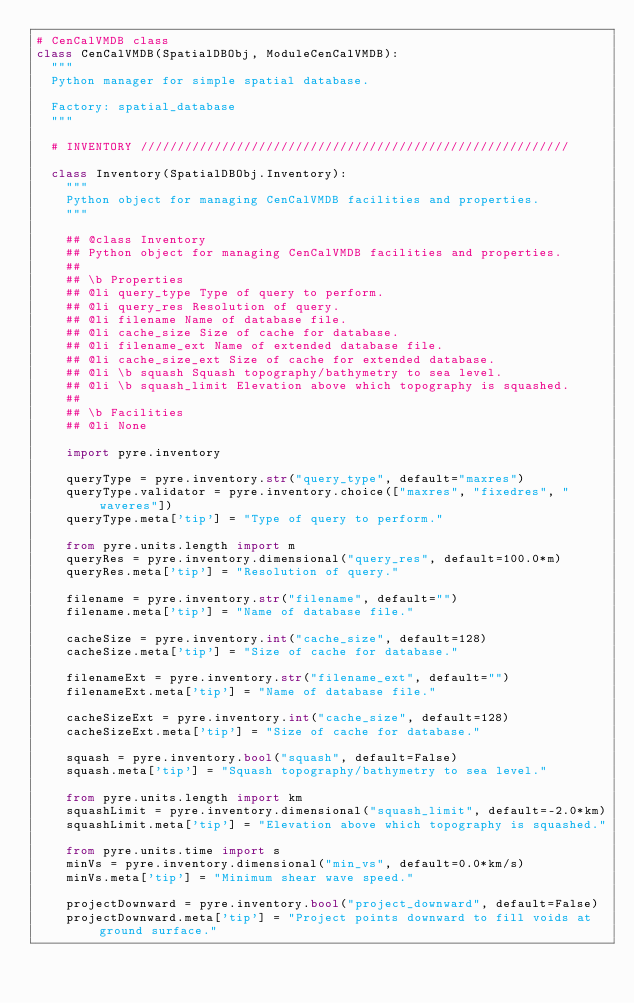<code> <loc_0><loc_0><loc_500><loc_500><_Python_># CenCalVMDB class
class CenCalVMDB(SpatialDBObj, ModuleCenCalVMDB):
  """
  Python manager for simple spatial database.

  Factory: spatial_database
  """

  # INVENTORY //////////////////////////////////////////////////////////

  class Inventory(SpatialDBObj.Inventory):
    """
    Python object for managing CenCalVMDB facilities and properties.
    """

    ## @class Inventory
    ## Python object for managing CenCalVMDB facilities and properties.
    ##
    ## \b Properties
    ## @li query_type Type of query to perform.
    ## @li query_res Resolution of query.
    ## @li filename Name of database file.
    ## @li cache_size Size of cache for database.
    ## @li filename_ext Name of extended database file.
    ## @li cache_size_ext Size of cache for extended database.
    ## @li \b squash Squash topography/bathymetry to sea level.
    ## @li \b squash_limit Elevation above which topography is squashed.
    ##
    ## \b Facilities
    ## @li None

    import pyre.inventory

    queryType = pyre.inventory.str("query_type", default="maxres")
    queryType.validator = pyre.inventory.choice(["maxres", "fixedres", "waveres"])
    queryType.meta['tip'] = "Type of query to perform."

    from pyre.units.length import m
    queryRes = pyre.inventory.dimensional("query_res", default=100.0*m)
    queryRes.meta['tip'] = "Resolution of query."

    filename = pyre.inventory.str("filename", default="")
    filename.meta['tip'] = "Name of database file."

    cacheSize = pyre.inventory.int("cache_size", default=128)
    cacheSize.meta['tip'] = "Size of cache for database."

    filenameExt = pyre.inventory.str("filename_ext", default="")
    filenameExt.meta['tip'] = "Name of database file."

    cacheSizeExt = pyre.inventory.int("cache_size", default=128)
    cacheSizeExt.meta['tip'] = "Size of cache for database."

    squash = pyre.inventory.bool("squash", default=False)
    squash.meta['tip'] = "Squash topography/bathymetry to sea level."

    from pyre.units.length import km
    squashLimit = pyre.inventory.dimensional("squash_limit", default=-2.0*km)
    squashLimit.meta['tip'] = "Elevation above which topography is squashed."

    from pyre.units.time import s
    minVs = pyre.inventory.dimensional("min_vs", default=0.0*km/s)
    minVs.meta['tip'] = "Minimum shear wave speed."
    
    projectDownward = pyre.inventory.bool("project_downward", default=False)
    projectDownward.meta['tip'] = "Project points downward to fill voids at ground surface."
    
</code> 